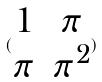Convert formula to latex. <formula><loc_0><loc_0><loc_500><loc_500>( \begin{matrix} 1 & \pi \\ \pi & \pi ^ { 2 } \end{matrix} )</formula> 